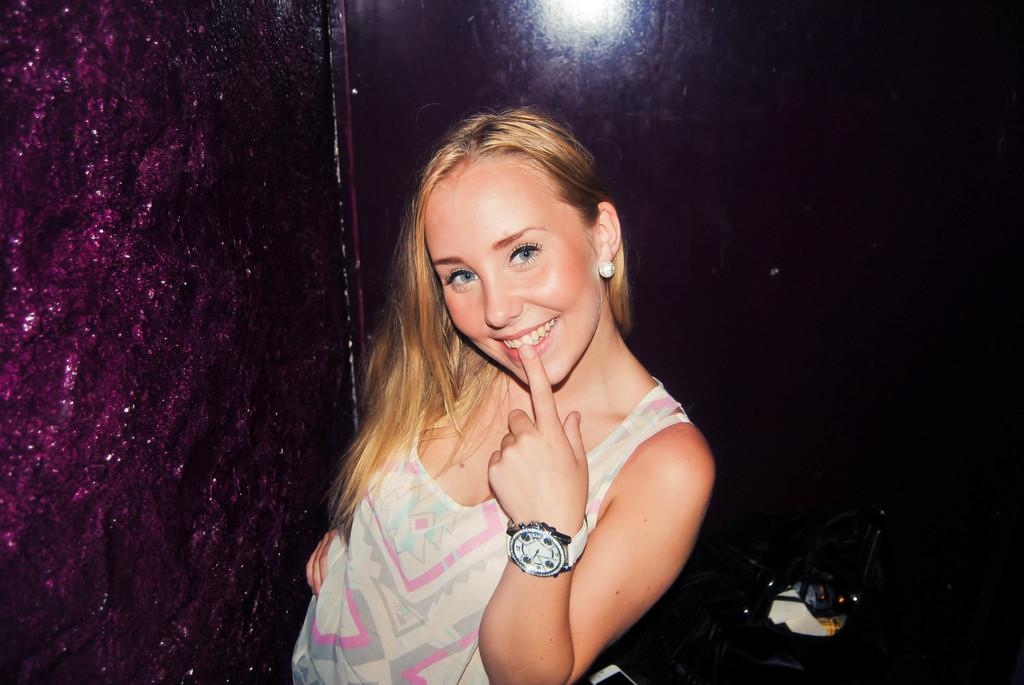Who is in the image? There is a woman in the image. What is the woman wearing on her upper body? The woman is wearing a t-shirt. What accessory is the woman wearing on her wrist? The woman is wearing a watch. What is the woman doing with her finger in the image? The woman is placing a finger on her lip. What expression does the woman have in the image? The woman is smiling. What is the woman's posture in the image? The woman is standing. What object can be seen on the table in the image? There is a mobile on the table in the image. What is visible in the background of the image? There is a wall in the image, and the background is dark in color. What type of pest can be seen crawling on the woman's arm in the image? There are no pests visible on the woman's arm in the image. What kind of snack is the woman holding in the image? The image does not show the woman holding any snack, such as popcorn. 